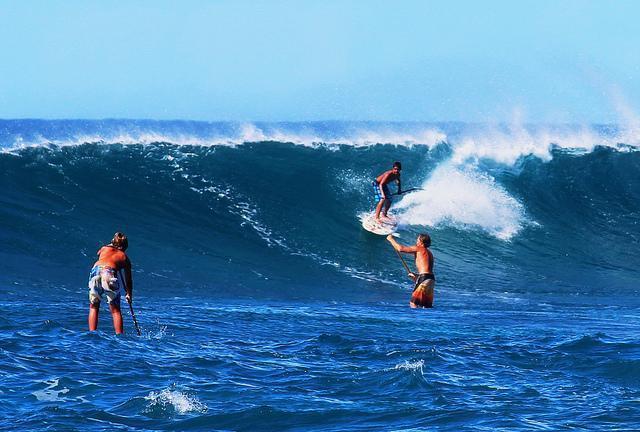How many people in the water?
Give a very brief answer. 3. 